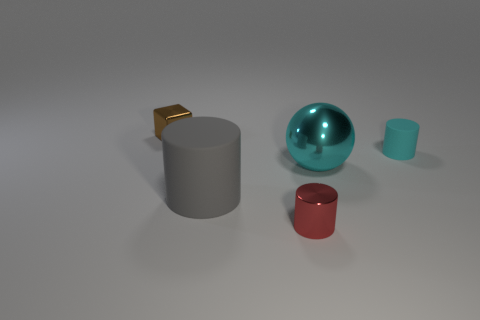Subtract all tiny cylinders. How many cylinders are left? 1 Add 3 brown metal objects. How many objects exist? 8 Subtract 0 yellow cylinders. How many objects are left? 5 Subtract all spheres. How many objects are left? 4 Subtract all large cylinders. Subtract all blue cubes. How many objects are left? 4 Add 3 cyan metal balls. How many cyan metal balls are left? 4 Add 5 small brown shiny blocks. How many small brown shiny blocks exist? 6 